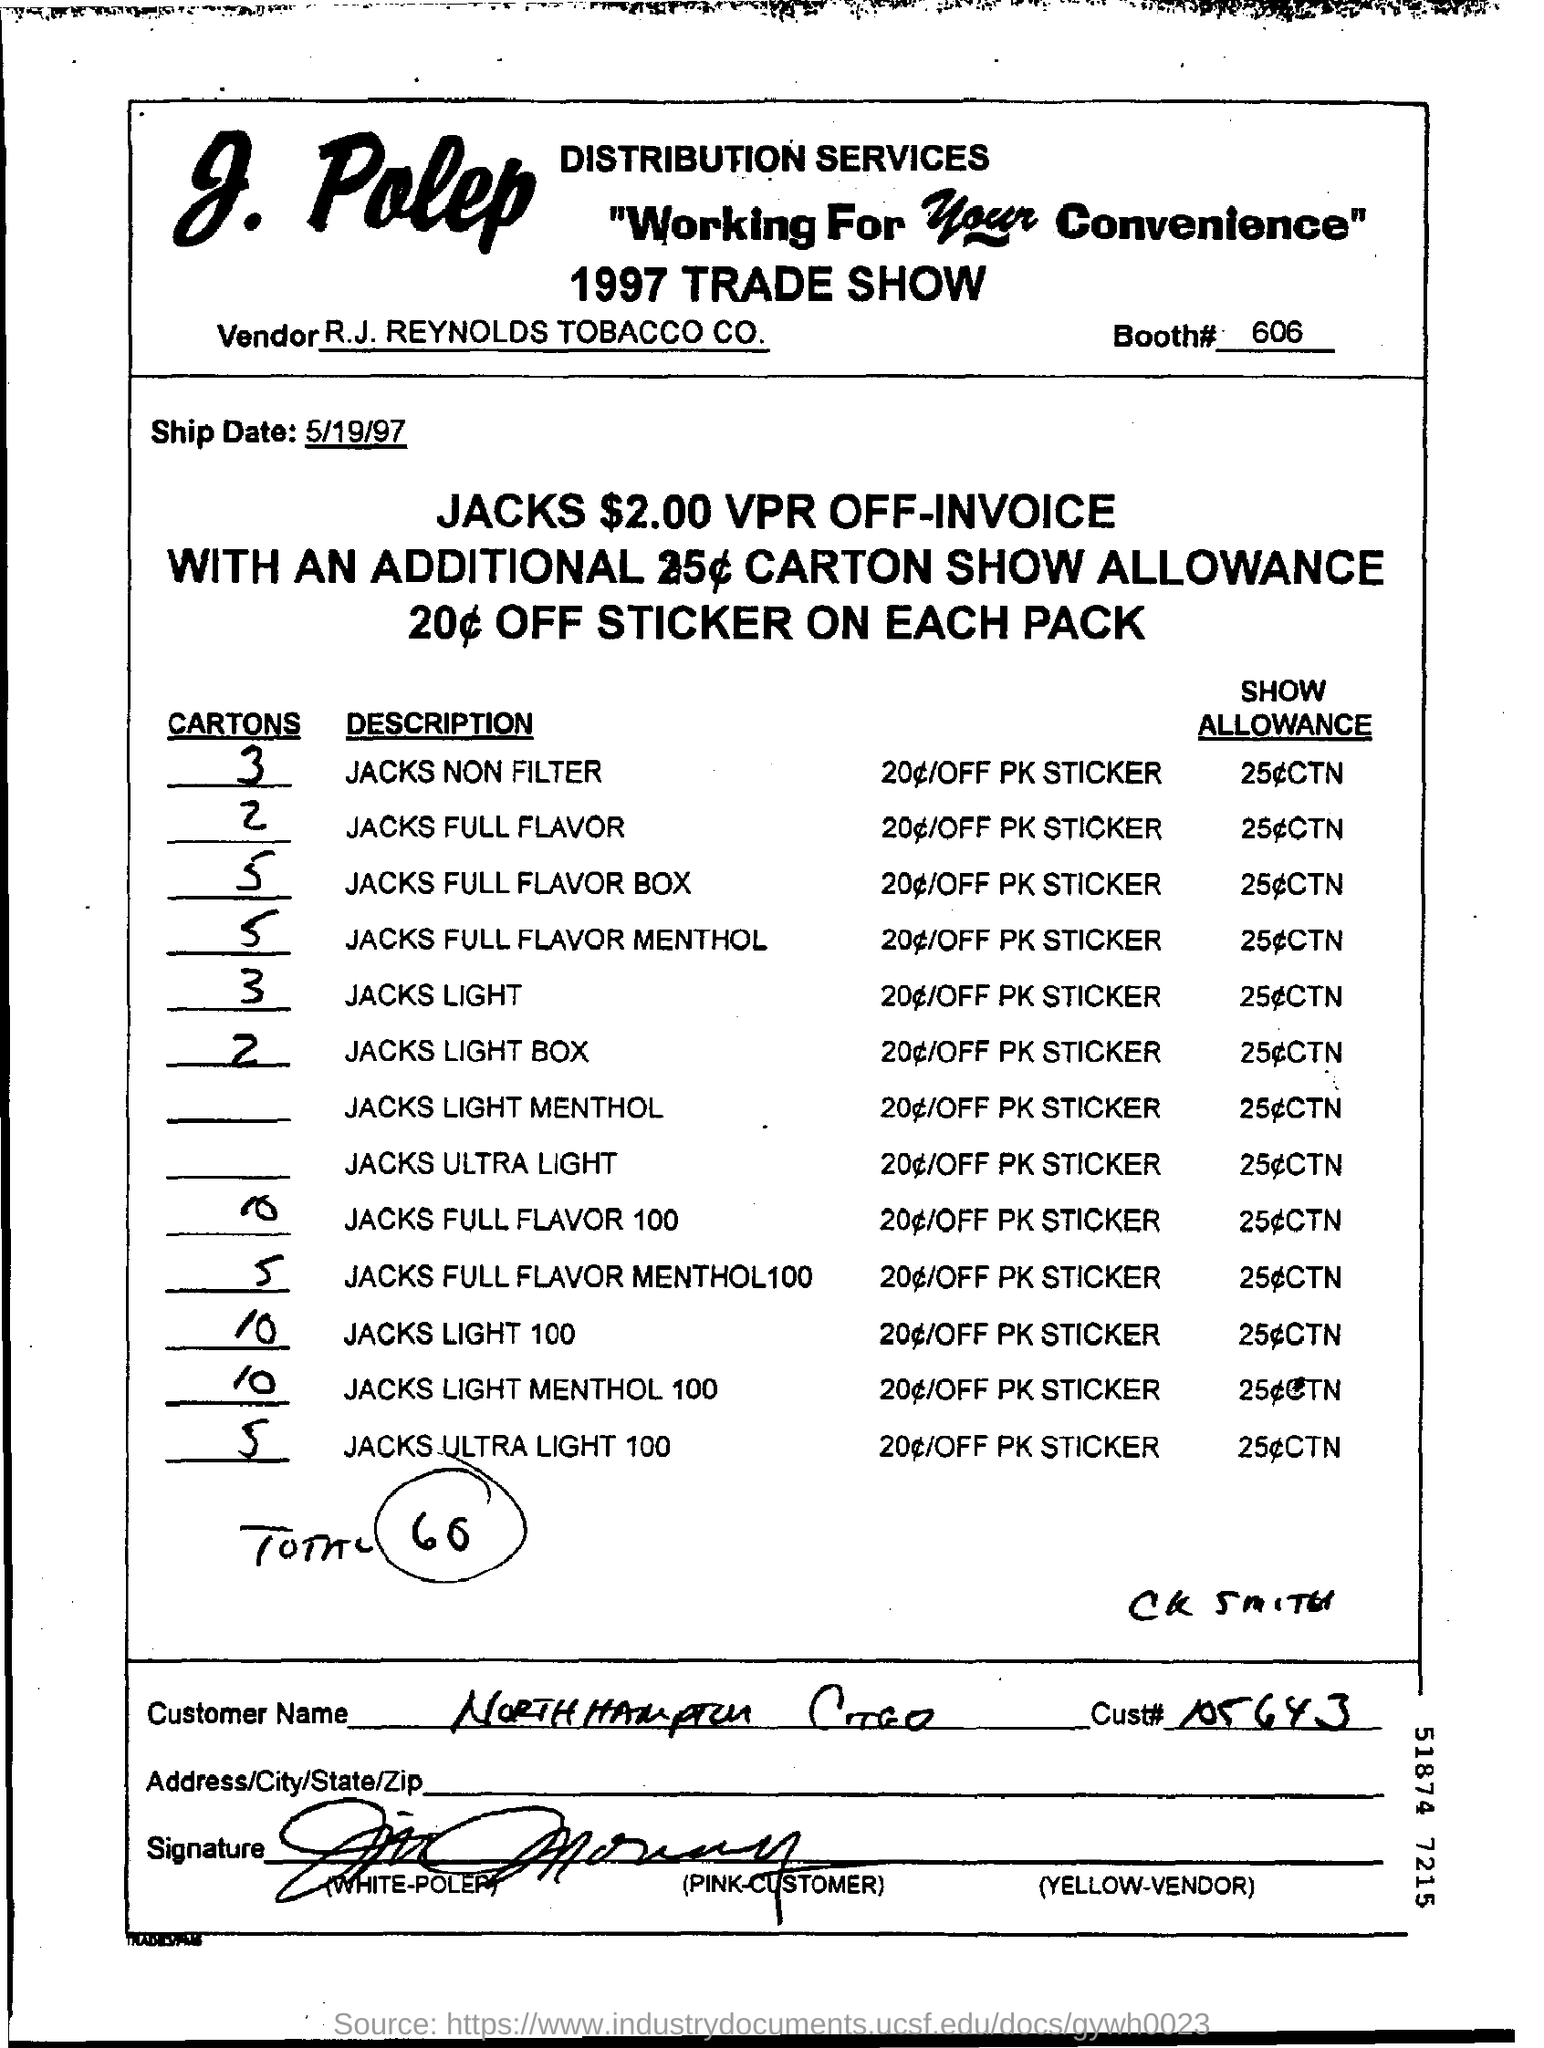Outline some significant characteristics in this image. R.J. Reynolds Tobacco Company is a vendor mentioned in the quote. The ship date mentioned is 5/19/97. There are three non-filter cartons mentioned. There are 2 jacks full flavor cartons that are mentioned. The booth number mentioned is 606. 